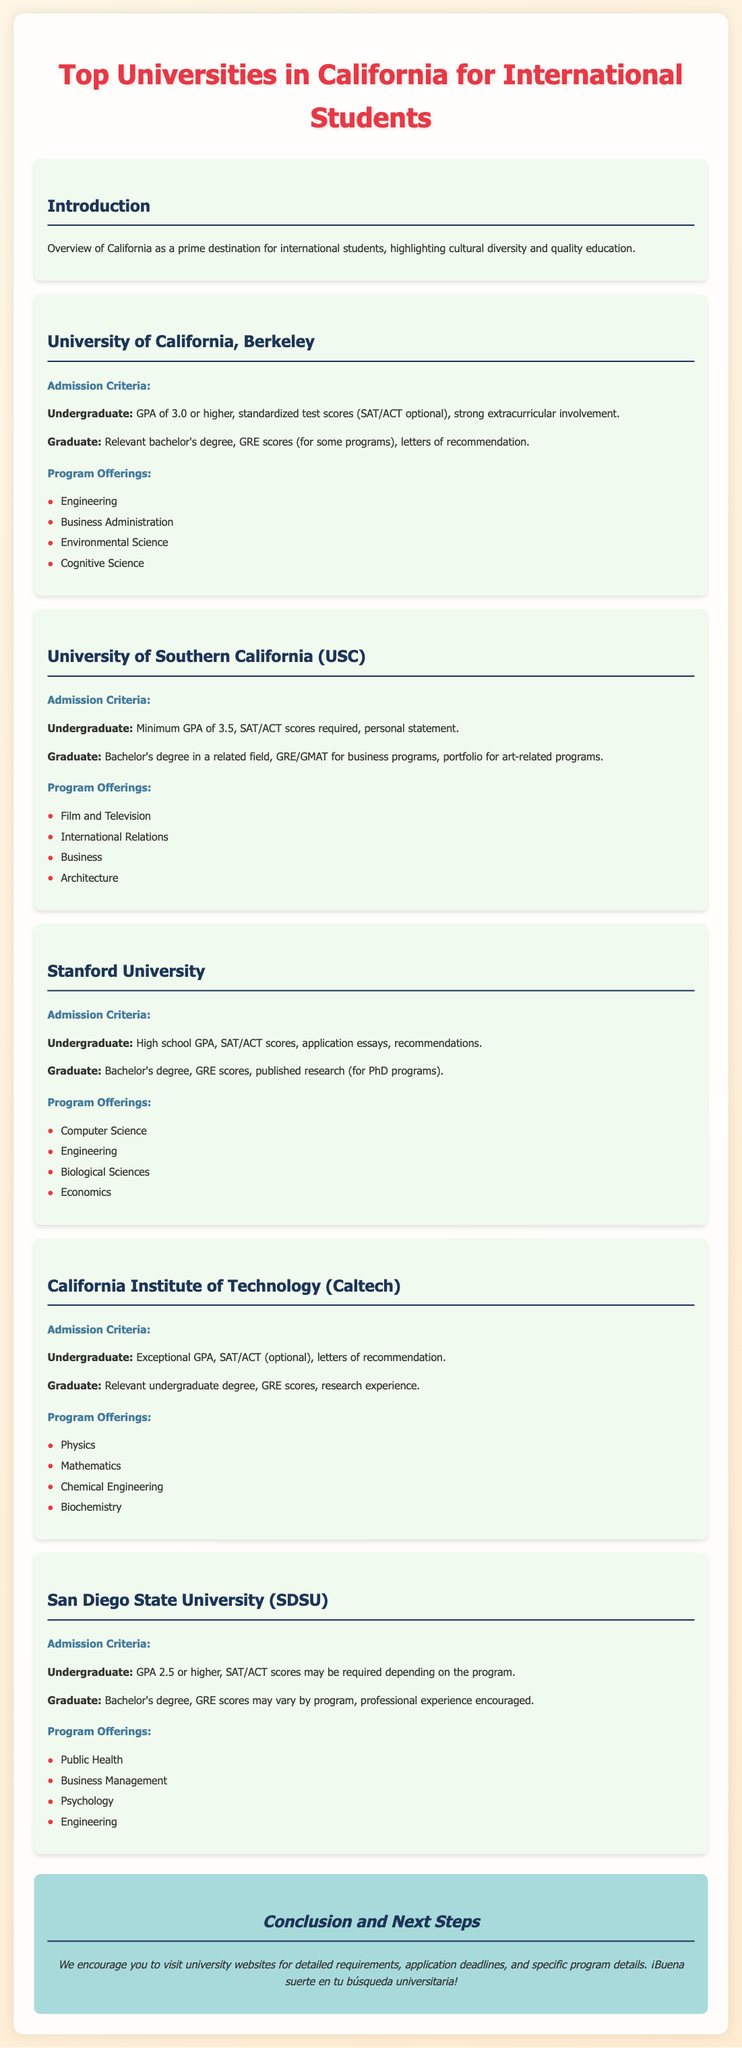What is the undergraduate GPA requirement for UC Berkeley? The document states that UC Berkeley requires a GPA of 3.0 or higher for undergraduate admission.
Answer: 3.0 What standardized test scores are optional for UC Berkeley undergraduates? The document mentions that SAT/ACT scores are optional for undergraduate admission at UC Berkeley.
Answer: SAT/ACT What is the maximum GPA for admission to USC? The document indicates that a minimum GPA of 3.5 is required for undergraduate admission to USC.
Answer: 3.5 What is one program offering at Stanford University? The document lists several program offerings for Stanford, including Computer Science.
Answer: Computer Science What is a graduate admission requirement for USC? The document states that a bachelor's degree in a related field is required for graduate admission at USC.
Answer: Bachelor's degree Which university offers a program in Public Health? The document specifies that San Diego State University offers a program in Public Health.
Answer: San Diego State University What is a common admission requirement for graduate programs across most universities listed? The document highlights that a relevant bachelor's degree is commonly required for graduate programs.
Answer: Relevant bachelor's degree What is the conclusion's suggested next step for students? The document encourages students to visit university websites for detailed requirements and application deadlines.
Answer: Visit university websites What is a unique aspect of the culture in California mentioned in the overview? The overview highlights cultural diversity as a prime aspect of California for international students.
Answer: Cultural diversity 